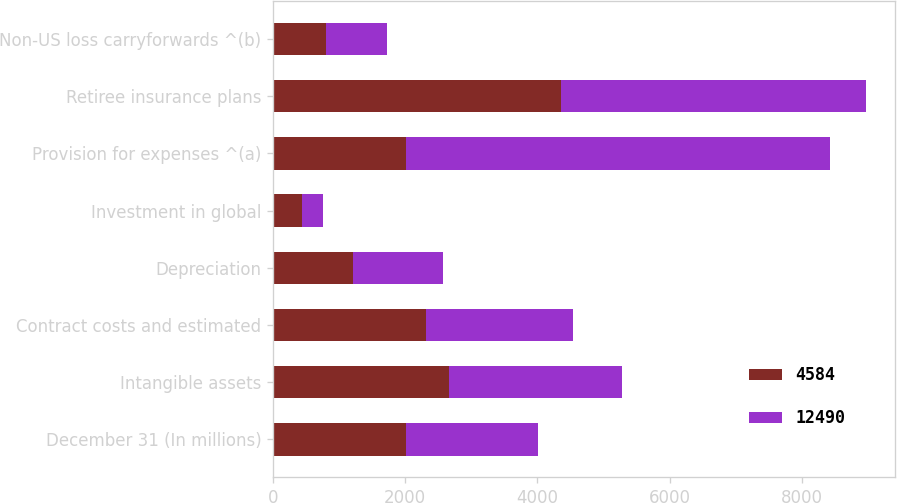Convert chart to OTSL. <chart><loc_0><loc_0><loc_500><loc_500><stacked_bar_chart><ecel><fcel>December 31 (In millions)<fcel>Intangible assets<fcel>Contract costs and estimated<fcel>Depreciation<fcel>Investment in global<fcel>Provision for expenses ^(a)<fcel>Retiree insurance plans<fcel>Non-US loss carryforwards ^(b)<nl><fcel>4584<fcel>2008<fcel>2664<fcel>2319<fcel>1205<fcel>444<fcel>2008<fcel>4355<fcel>800<nl><fcel>12490<fcel>2007<fcel>2609<fcel>2215<fcel>1360<fcel>318<fcel>6426<fcel>4616<fcel>925<nl></chart> 